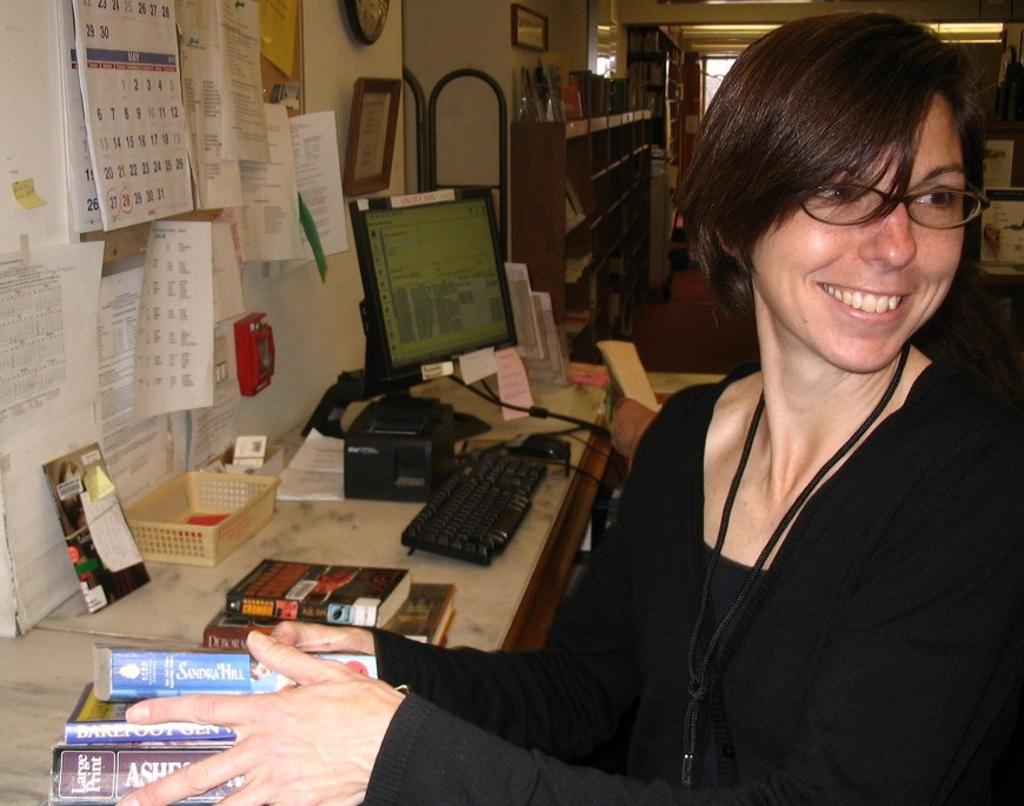What is the main object in the center of the image? There is a table in the center of the image. What can be found on the table? There are many objects on the table. Can you describe the person in the image? There is a lady in the image. What is the lady holding in her hands? The lady is holding books in her hands. What type of wood is the girl using to build a birdhouse in the image? There is no girl present in the image, and no birdhouse or wood can be seen. 